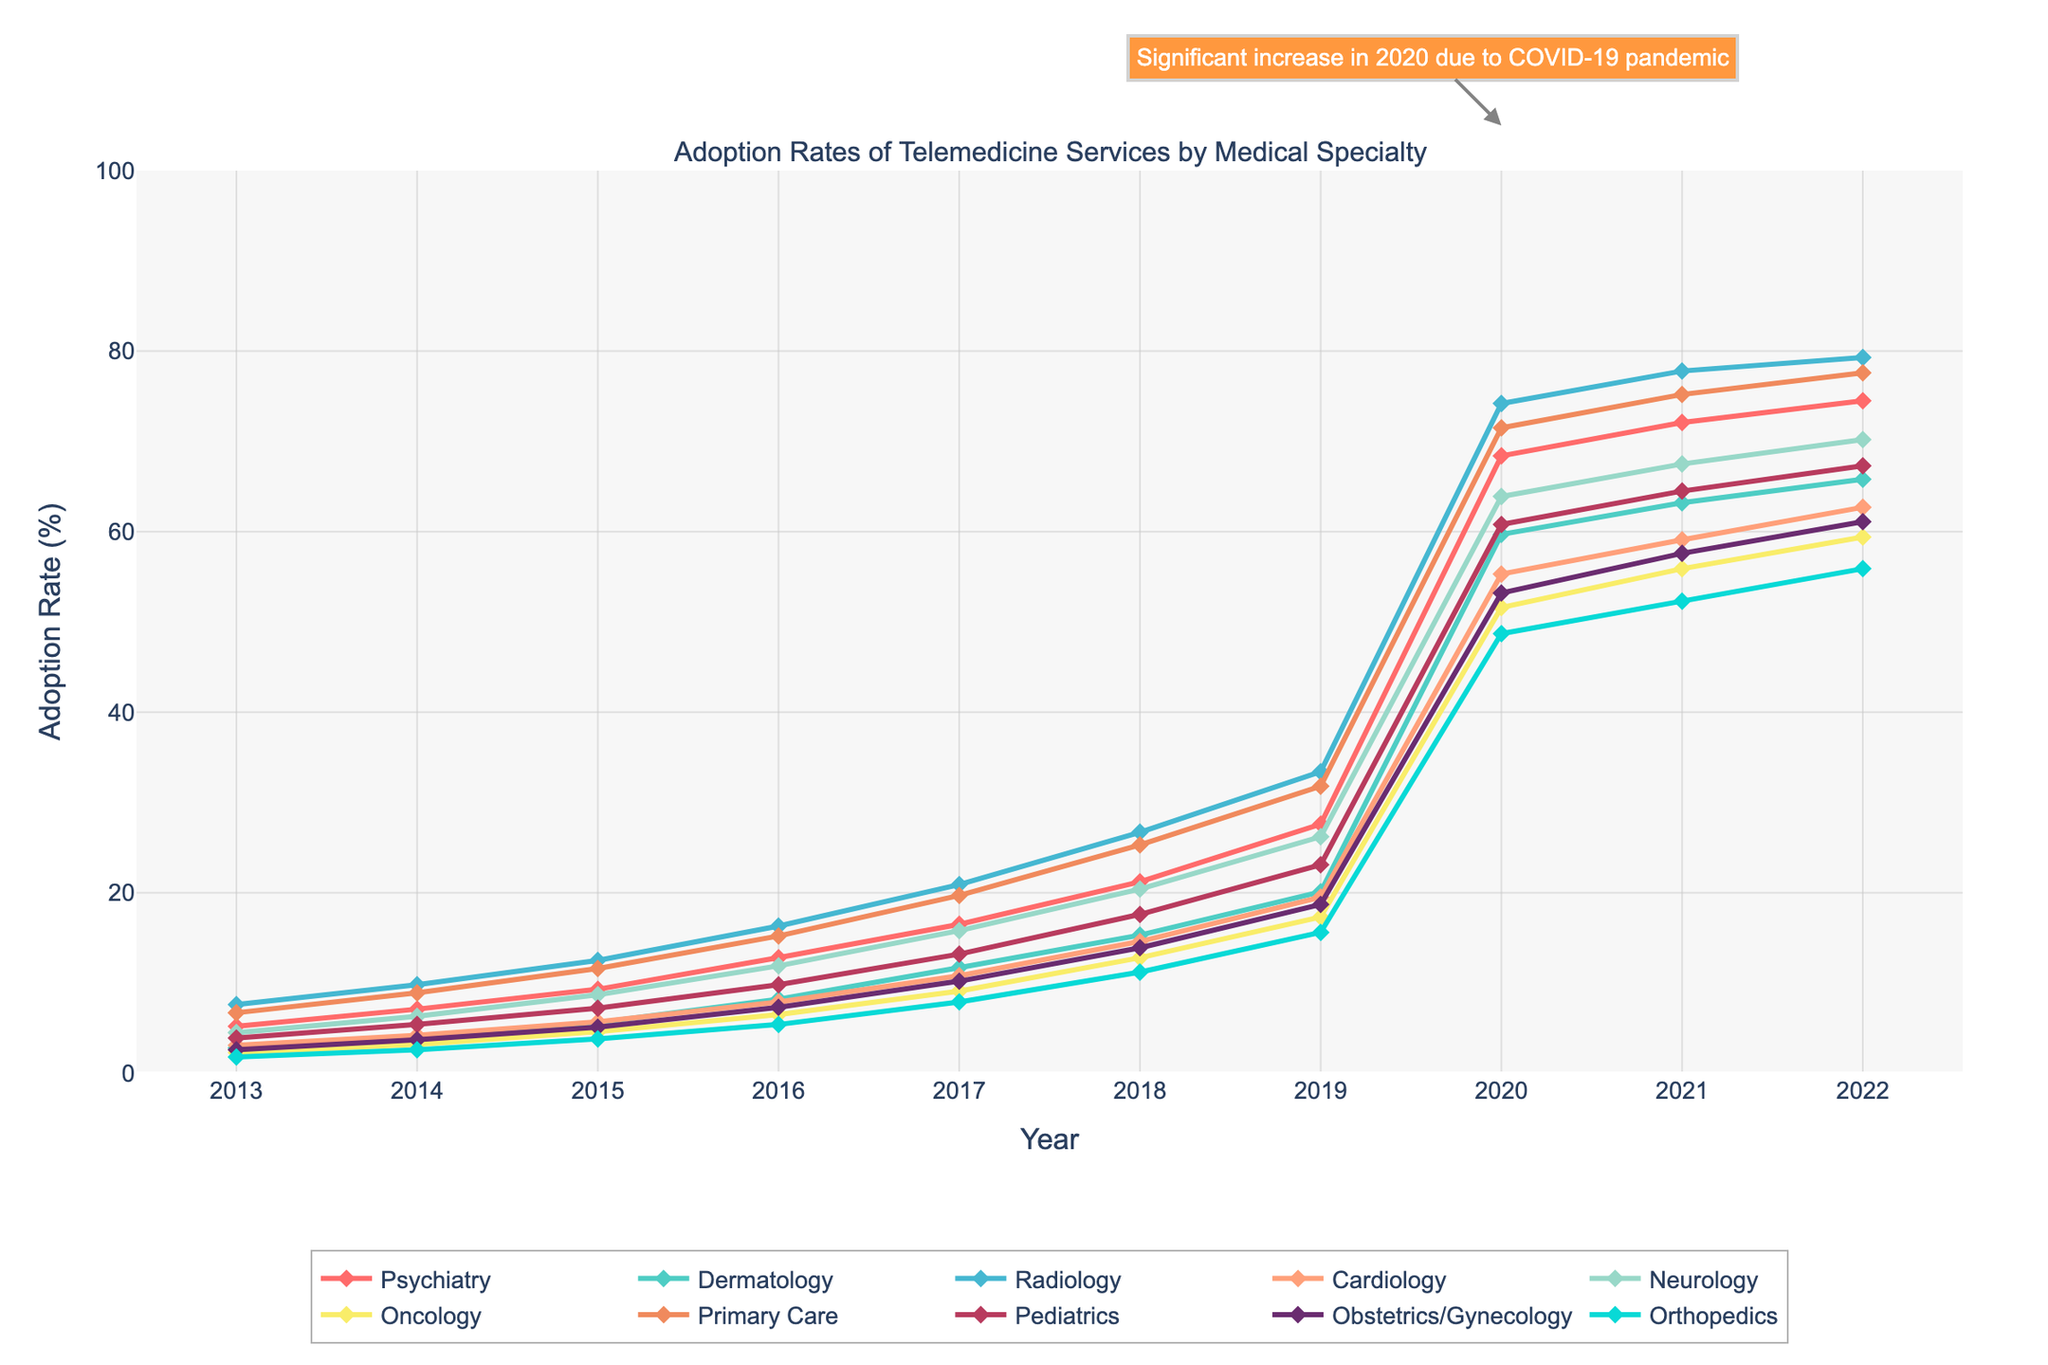What's the average adoption rate of telemedicine services for Radiology in the years 2013 to 2016? To find the average adoption rate for Radiology from 2013 to 2016, sum the adoption rates for these years: 7.6, 9.8, 12.5, 16.3. The sum is 46.2. Then, divide by the number of years, which is 4. The average adoption rate is 46.2/4 = 11.55
Answer: 11.55 Which specialty had the highest adoption rate of telemedicine services in 2020? To determine which specialty had the highest adoption rate in 2020, look at the values for each specialty in 2020. The values are: Psychiatry (68.4), Dermatology (59.7), Radiology (74.2), Cardiology (55.3), Neurology (63.9), Oncology (51.6), Primary Care (71.5), Pediatrics (60.8), Obstetrics/Gynecology (53.2), Orthopedics (48.7). Radiology had the highest rate at 74.2%.
Answer: Radiology How much did the adoption rate for Oncology increase from 2019 to 2020? To find the increase in the adoption rate for Oncology from 2019 to 2020, subtract the 2019 rate from the 2020 rate: 51.6 - 17.3 = 34.3. The increase is 34.3%.
Answer: 34.3 Which specialty showed the largest increase in adoption rates between 2019 and 2022? Find the increase from 2019 to 2022 for each specialty and compare: Psychiatry (74.5 - 27.6 = 46.9), Dermatology (65.8 - 20.1 = 45.7), Radiology (79.3 - 33.4 = 45.9), Cardiology (62.7 - 19.5 = 43.2), Neurology (70.2 - 26.2 = 44.0), Oncology (59.4 - 17.3 = 42.1), Primary Care (77.6 - 31.8 = 45.8), Pediatrics (67.3 - 23.1 = 44.2), Obstetrics/Gynecology (61.1 - 18.7 = 42.4), Orthopedics (55.9 - 15.6 = 40.3). Psychiatry showed the largest increase of 46.9%.
Answer: Psychiatry Which two specialties had similar adoption rates in 2017 and how close were their rates? Compare the 2017 rates: Psychiatry (16.5), Dermatology (11.7), Radiology (20.9), Cardiology (10.8), Neurology (15.8), Oncology (9.1), Primary Care (19.7), Pediatrics (13.2), Obstetrics/Gynecology (10.2), Orthopedics (7.9). The closest rates are for Neurology (15.8) and Psychiatry (16.5); the difference is 16.5 - 15.8 = 0.7.
Answer: Neurology and Psychiatry, 0.7 What is the general trend in the adoption rates for all specialties from 2013 to 2022? Examine the lines for all specialties from 2013 to 2022. Each specialty shows an upward trend over this period, indicating increasing adoption rates for telemedicine services across all specialties.
Answer: Increasing trend Identify the specialty with the smallest adoption rate in 2013. What was the adoption rate? Look at the values for 2013: Psychiatry (5.2), Dermatology (2.8), Radiology (7.6), Cardiology (3.1), Neurology (4.5), Oncology (2.3), Primary Care (6.7), Pediatrics (3.9), Obstetrics/Gynecology (2.6), Orthopedics (1.8). Orthopedics had the smallest adoption rate in 2013 at 1.8%.
Answer: Orthopedics, 1.8 Between which consecutive years did Psychiatry see the largest increase in adoption rates, and what was the increase? Check the differences between consecutive years for Psychiatry: 2013 to 2014 (7.1 - 5.2 = 1.9), 2014 to 2015 (9.3 - 7.1 = 2.2), 2015 to 2016 (12.8 - 9.3 = 3.5), 2016 to 2017 (16.5 - 12.8 = 3.7), 2017 to 2018 (21.2 - 16.5 = 4.7), 2018 to 2019 (27.6 - 21.2 = 6.4), 2019 to 2020 (68.4 - 27.6 = 40.8), 2020 to 2021 (72.1 - 68.4 = 3.7), 2021 to 2022 (74.5 - 72.1 = 2.4). The largest increase was from 2019 to 2020 with an increase of 40.8.
Answer: 2019 to 2020, 40.8% 